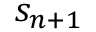Convert formula to latex. <formula><loc_0><loc_0><loc_500><loc_500>s _ { n + 1 }</formula> 